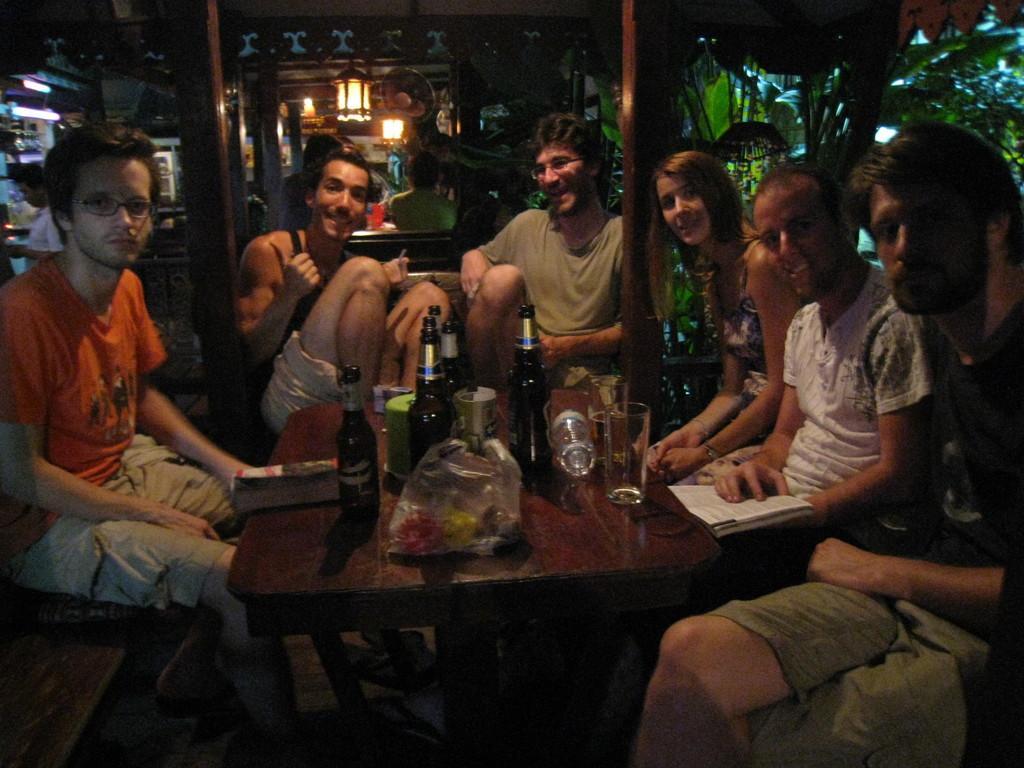Describe this image in one or two sentences. In this image I can see number of people are sitting. Here on the table I can see few bottles, few glasses and a book. 